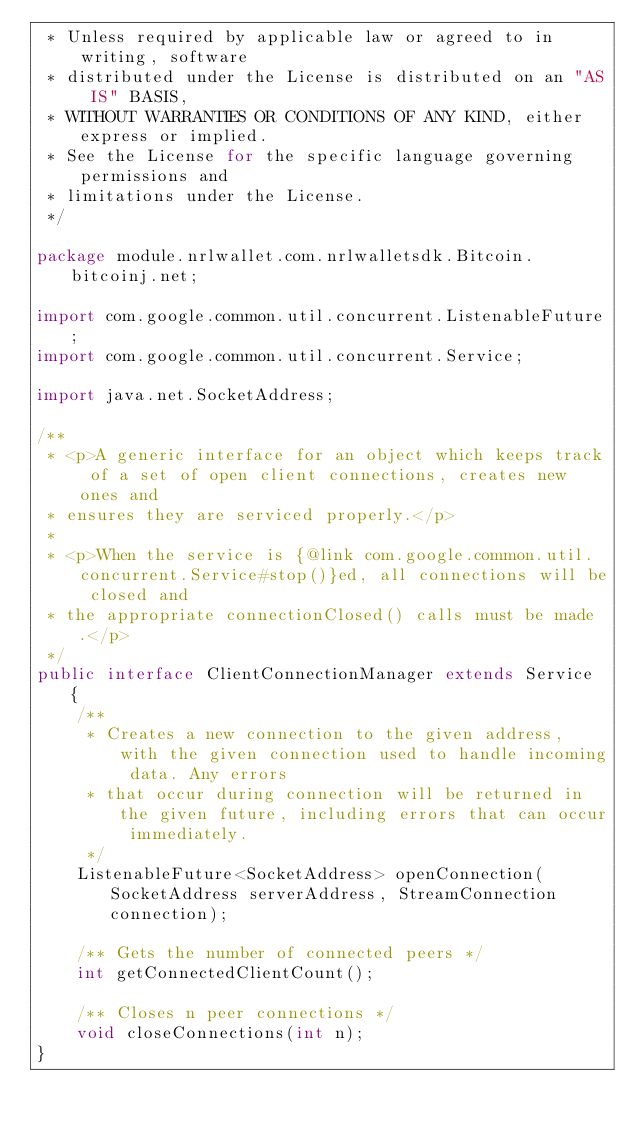Convert code to text. <code><loc_0><loc_0><loc_500><loc_500><_Java_> * Unless required by applicable law or agreed to in writing, software
 * distributed under the License is distributed on an "AS IS" BASIS,
 * WITHOUT WARRANTIES OR CONDITIONS OF ANY KIND, either express or implied.
 * See the License for the specific language governing permissions and
 * limitations under the License.
 */

package module.nrlwallet.com.nrlwalletsdk.Bitcoin.bitcoinj.net;

import com.google.common.util.concurrent.ListenableFuture;
import com.google.common.util.concurrent.Service;

import java.net.SocketAddress;

/**
 * <p>A generic interface for an object which keeps track of a set of open client connections, creates new ones and
 * ensures they are serviced properly.</p>
 *
 * <p>When the service is {@link com.google.common.util.concurrent.Service#stop()}ed, all connections will be closed and
 * the appropriate connectionClosed() calls must be made.</p>
 */
public interface ClientConnectionManager extends Service {
    /**
     * Creates a new connection to the given address, with the given connection used to handle incoming data. Any errors
     * that occur during connection will be returned in the given future, including errors that can occur immediately.
     */
    ListenableFuture<SocketAddress> openConnection(SocketAddress serverAddress, StreamConnection connection);

    /** Gets the number of connected peers */
    int getConnectedClientCount();

    /** Closes n peer connections */
    void closeConnections(int n);
}
</code> 